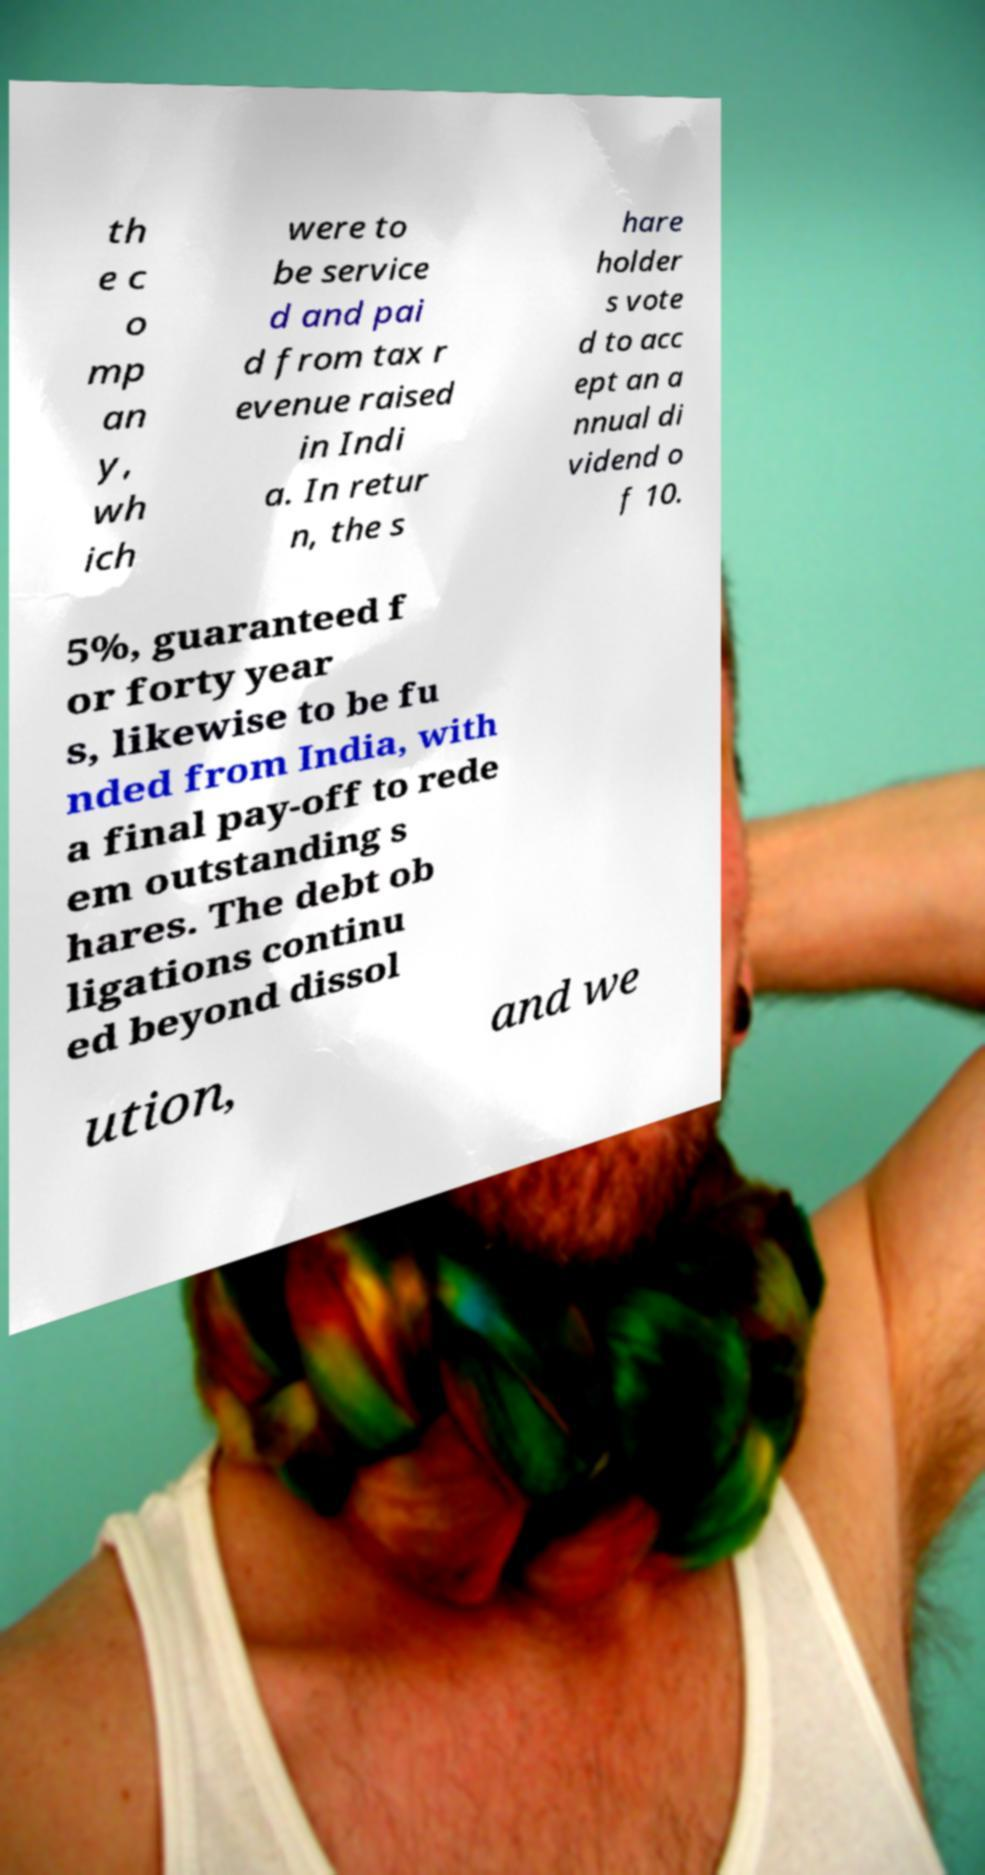Can you accurately transcribe the text from the provided image for me? th e c o mp an y, wh ich were to be service d and pai d from tax r evenue raised in Indi a. In retur n, the s hare holder s vote d to acc ept an a nnual di vidend o f 10. 5%, guaranteed f or forty year s, likewise to be fu nded from India, with a final pay-off to rede em outstanding s hares. The debt ob ligations continu ed beyond dissol ution, and we 